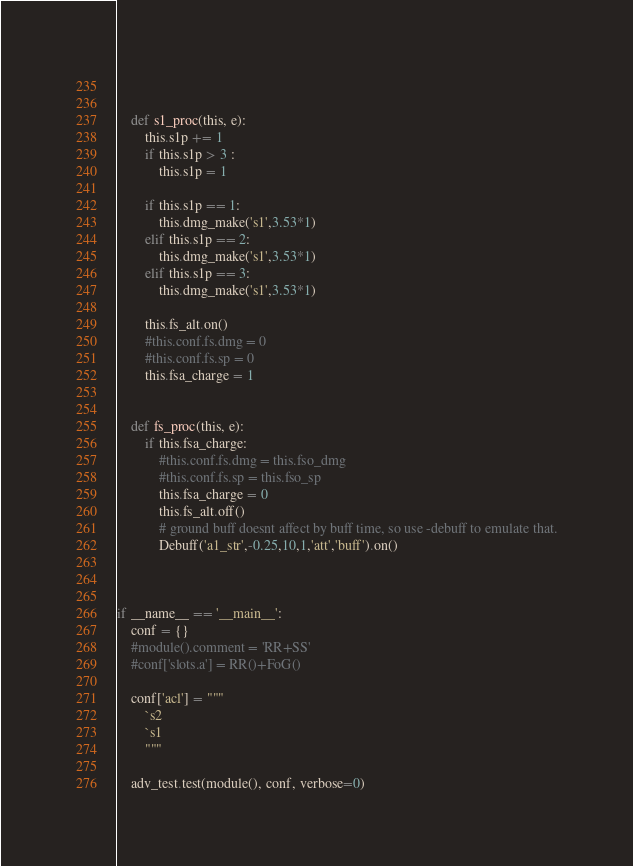Convert code to text. <code><loc_0><loc_0><loc_500><loc_500><_Python_>
        

    def s1_proc(this, e):
        this.s1p += 1
        if this.s1p > 3 :
            this.s1p = 1

        if this.s1p == 1:
            this.dmg_make('s1',3.53*1)
        elif this.s1p == 2:
            this.dmg_make('s1',3.53*1)
        elif this.s1p == 3:
            this.dmg_make('s1',3.53*1)

        this.fs_alt.on()
        #this.conf.fs.dmg = 0
        #this.conf.fs.sp = 0
        this.fsa_charge = 1


    def fs_proc(this, e):
        if this.fsa_charge:
            #this.conf.fs.dmg = this.fso_dmg
            #this.conf.fs.sp = this.fso_sp
            this.fsa_charge = 0
            this.fs_alt.off()
            # ground buff doesnt affect by buff time, so use -debuff to emulate that.
            Debuff('a1_str',-0.25,10,1,'att','buff').on()



if __name__ == '__main__':
    conf = {}
    #module().comment = 'RR+SS'
    #conf['slots.a'] = RR()+FoG()

    conf['acl'] = """
        `s2
        `s1
        """

    adv_test.test(module(), conf, verbose=0)

</code> 